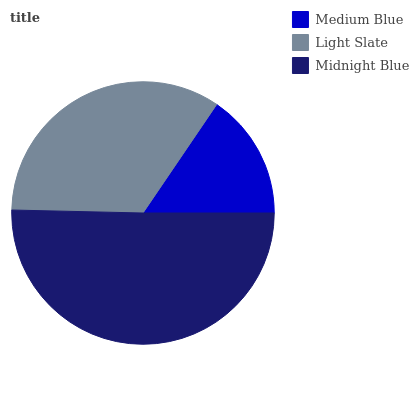Is Medium Blue the minimum?
Answer yes or no. Yes. Is Midnight Blue the maximum?
Answer yes or no. Yes. Is Light Slate the minimum?
Answer yes or no. No. Is Light Slate the maximum?
Answer yes or no. No. Is Light Slate greater than Medium Blue?
Answer yes or no. Yes. Is Medium Blue less than Light Slate?
Answer yes or no. Yes. Is Medium Blue greater than Light Slate?
Answer yes or no. No. Is Light Slate less than Medium Blue?
Answer yes or no. No. Is Light Slate the high median?
Answer yes or no. Yes. Is Light Slate the low median?
Answer yes or no. Yes. Is Midnight Blue the high median?
Answer yes or no. No. Is Medium Blue the low median?
Answer yes or no. No. 